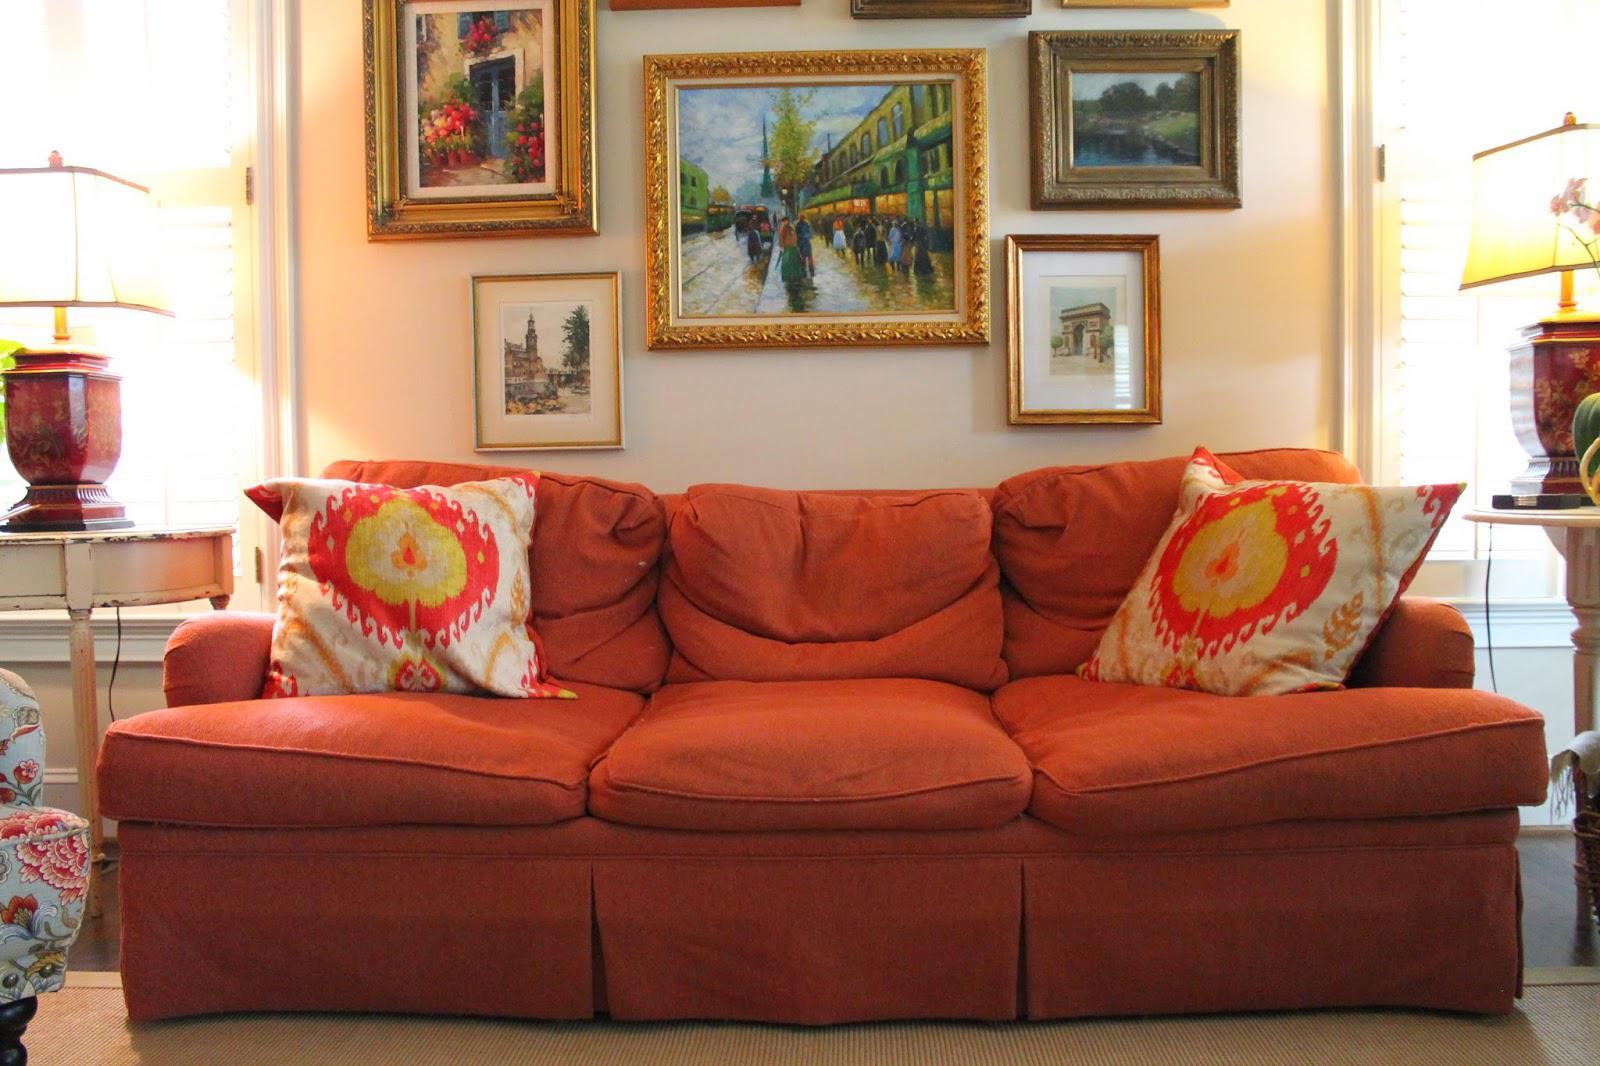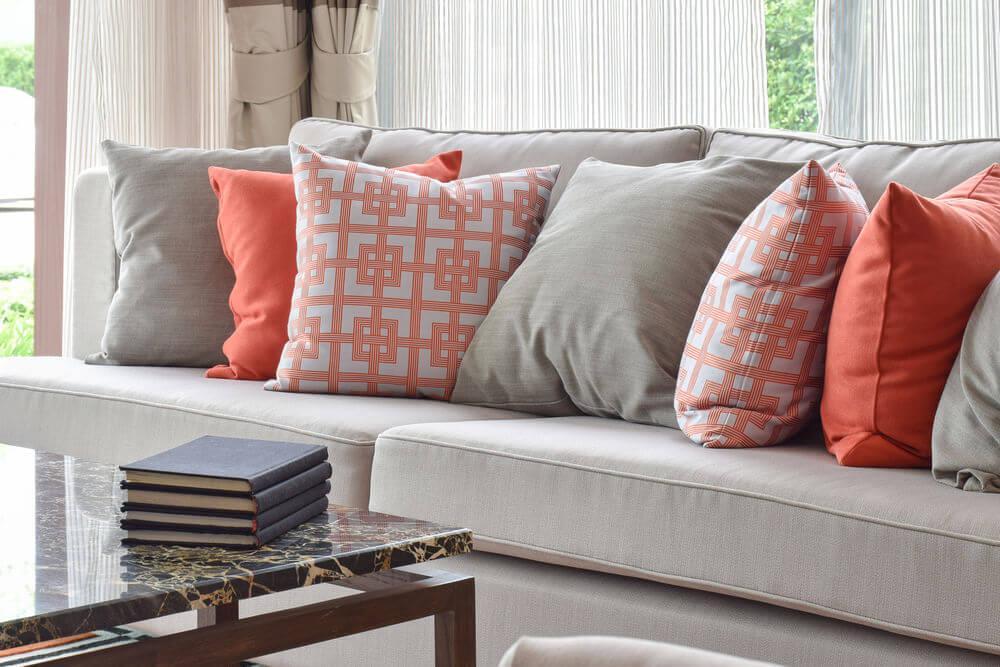The first image is the image on the left, the second image is the image on the right. Assess this claim about the two images: "Flowers in a vase are visible in the image on the right.". Correct or not? Answer yes or no. No. 